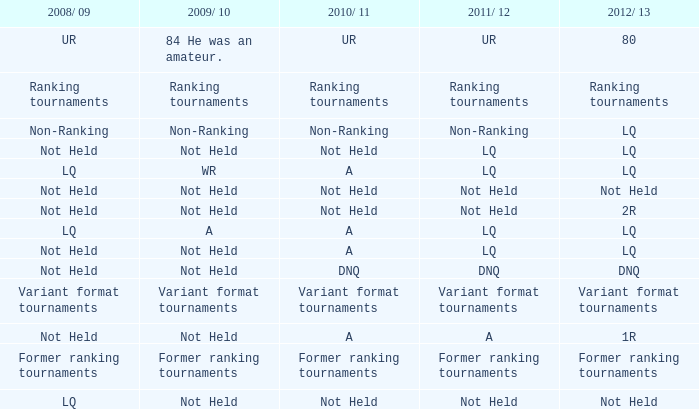When 2011/ 12 is non-ranking, what is the 2009/ 10? Non-Ranking. 